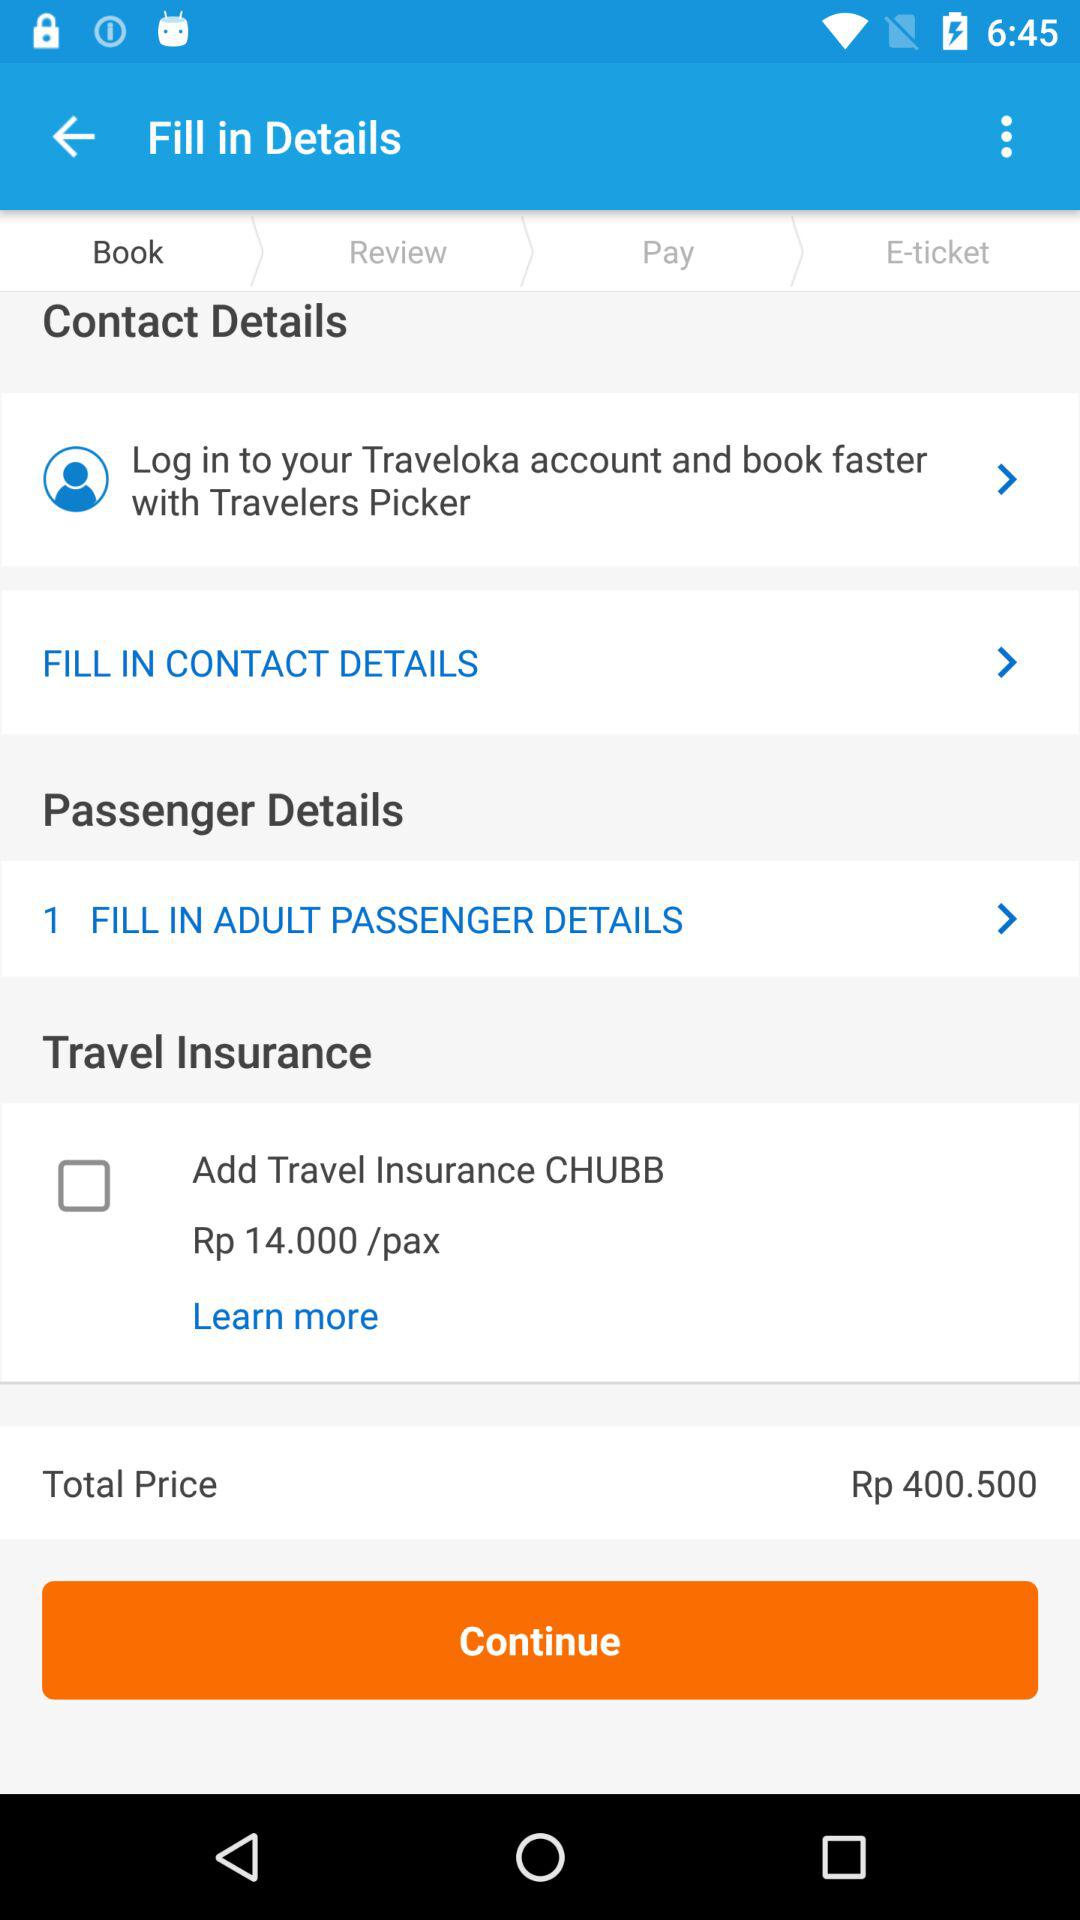What is the cost of the travel insurance? The cost of the travel insurance is Rp 14.0000 per pax. 